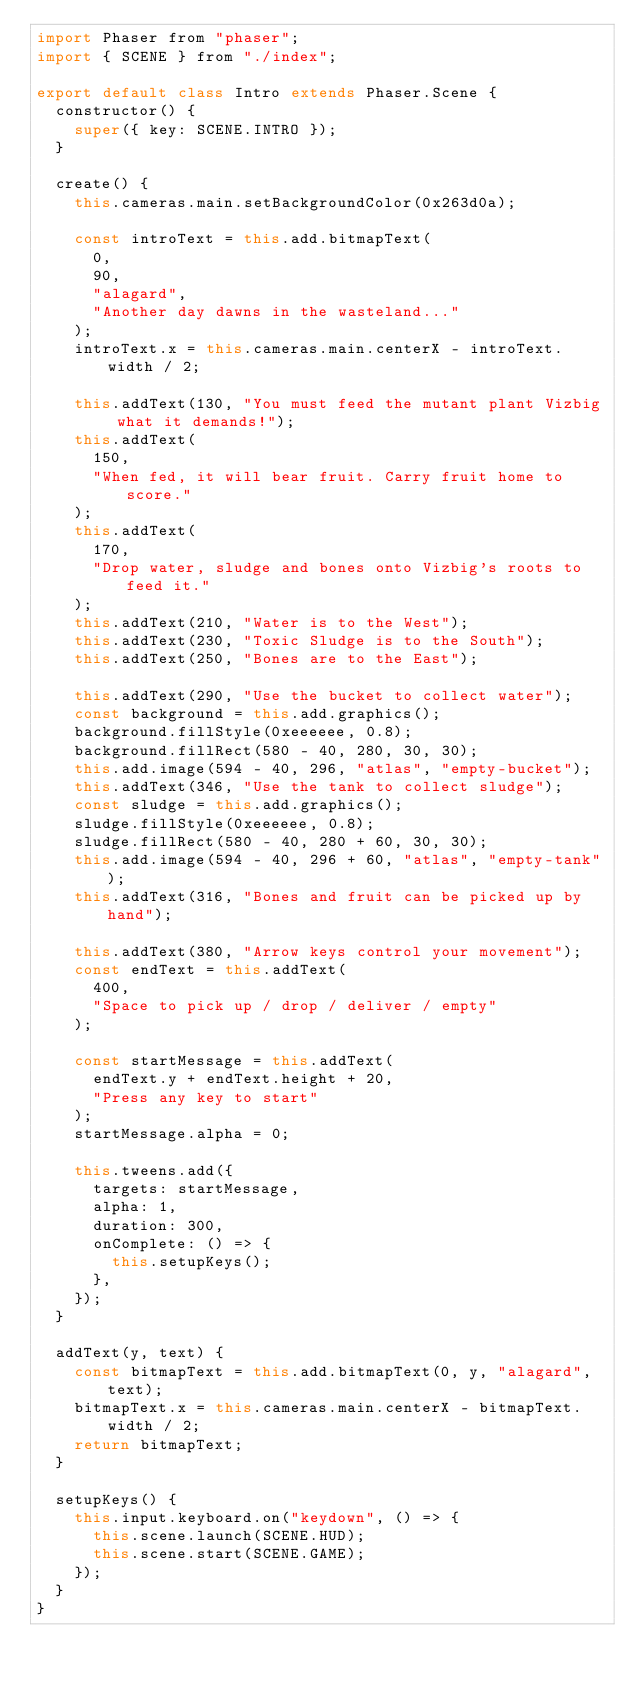Convert code to text. <code><loc_0><loc_0><loc_500><loc_500><_JavaScript_>import Phaser from "phaser";
import { SCENE } from "./index";

export default class Intro extends Phaser.Scene {
  constructor() {
    super({ key: SCENE.INTRO });
  }

  create() {
    this.cameras.main.setBackgroundColor(0x263d0a);

    const introText = this.add.bitmapText(
      0,
      90,
      "alagard",
      "Another day dawns in the wasteland..."
    );
    introText.x = this.cameras.main.centerX - introText.width / 2;

    this.addText(130, "You must feed the mutant plant Vizbig what it demands!");
    this.addText(
      150,
      "When fed, it will bear fruit. Carry fruit home to score."
    );
    this.addText(
      170,
      "Drop water, sludge and bones onto Vizbig's roots to feed it."
    );
    this.addText(210, "Water is to the West");
    this.addText(230, "Toxic Sludge is to the South");
    this.addText(250, "Bones are to the East");

    this.addText(290, "Use the bucket to collect water");
    const background = this.add.graphics();
    background.fillStyle(0xeeeeee, 0.8);
    background.fillRect(580 - 40, 280, 30, 30);
    this.add.image(594 - 40, 296, "atlas", "empty-bucket");
    this.addText(346, "Use the tank to collect sludge");
    const sludge = this.add.graphics();
    sludge.fillStyle(0xeeeeee, 0.8);
    sludge.fillRect(580 - 40, 280 + 60, 30, 30);
    this.add.image(594 - 40, 296 + 60, "atlas", "empty-tank");
    this.addText(316, "Bones and fruit can be picked up by hand");

    this.addText(380, "Arrow keys control your movement");
    const endText = this.addText(
      400,
      "Space to pick up / drop / deliver / empty"
    );

    const startMessage = this.addText(
      endText.y + endText.height + 20,
      "Press any key to start"
    );
    startMessage.alpha = 0;

    this.tweens.add({
      targets: startMessage,
      alpha: 1,
      duration: 300,
      onComplete: () => {
        this.setupKeys();
      },
    });
  }

  addText(y, text) {
    const bitmapText = this.add.bitmapText(0, y, "alagard", text);
    bitmapText.x = this.cameras.main.centerX - bitmapText.width / 2;
    return bitmapText;
  }

  setupKeys() {
    this.input.keyboard.on("keydown", () => {
      this.scene.launch(SCENE.HUD);
      this.scene.start(SCENE.GAME);
    });
  }
}
</code> 